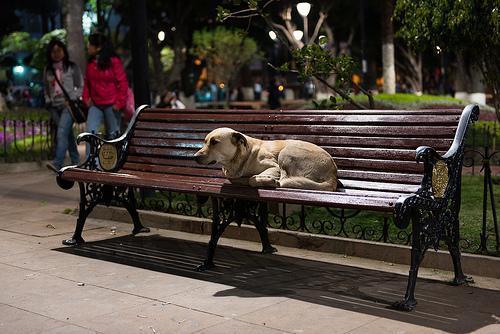How many dogs are there?
Give a very brief answer. 1. 